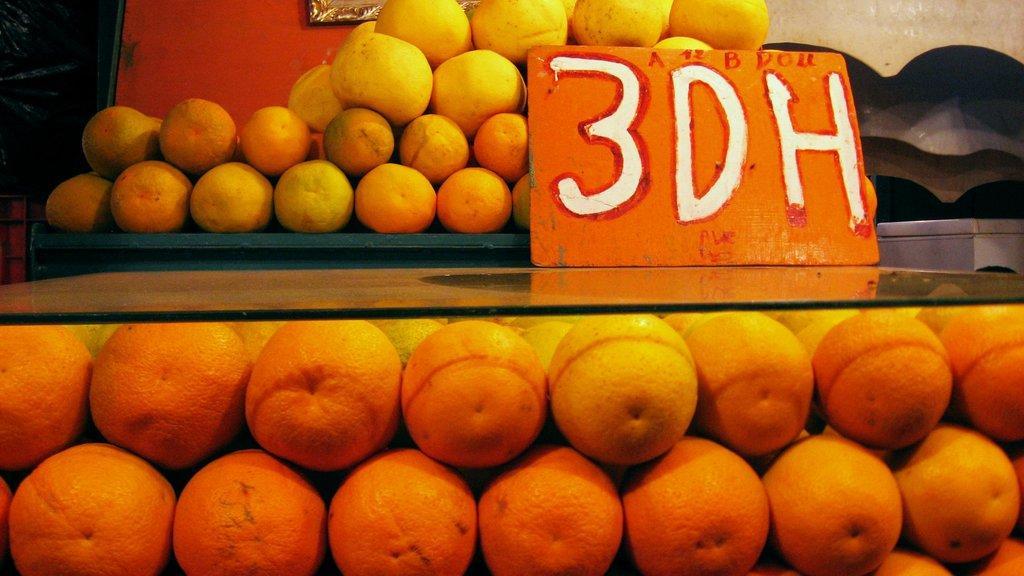Please provide a concise description of this image. There are oranges at the bottom side of the image, there is text on the small board, it seems like the frame and fruits at the top side. 